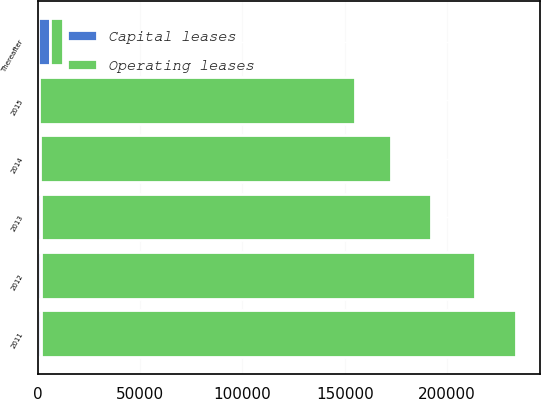Convert chart. <chart><loc_0><loc_0><loc_500><loc_500><stacked_bar_chart><ecel><fcel>2011<fcel>2012<fcel>2013<fcel>2014<fcel>2015<fcel>Thereafter<nl><fcel>Operating leases<fcel>232415<fcel>212126<fcel>190911<fcel>171474<fcel>154351<fcel>6066<nl><fcel>Capital leases<fcel>1387<fcel>1412<fcel>1382<fcel>1133<fcel>773<fcel>6066<nl></chart> 